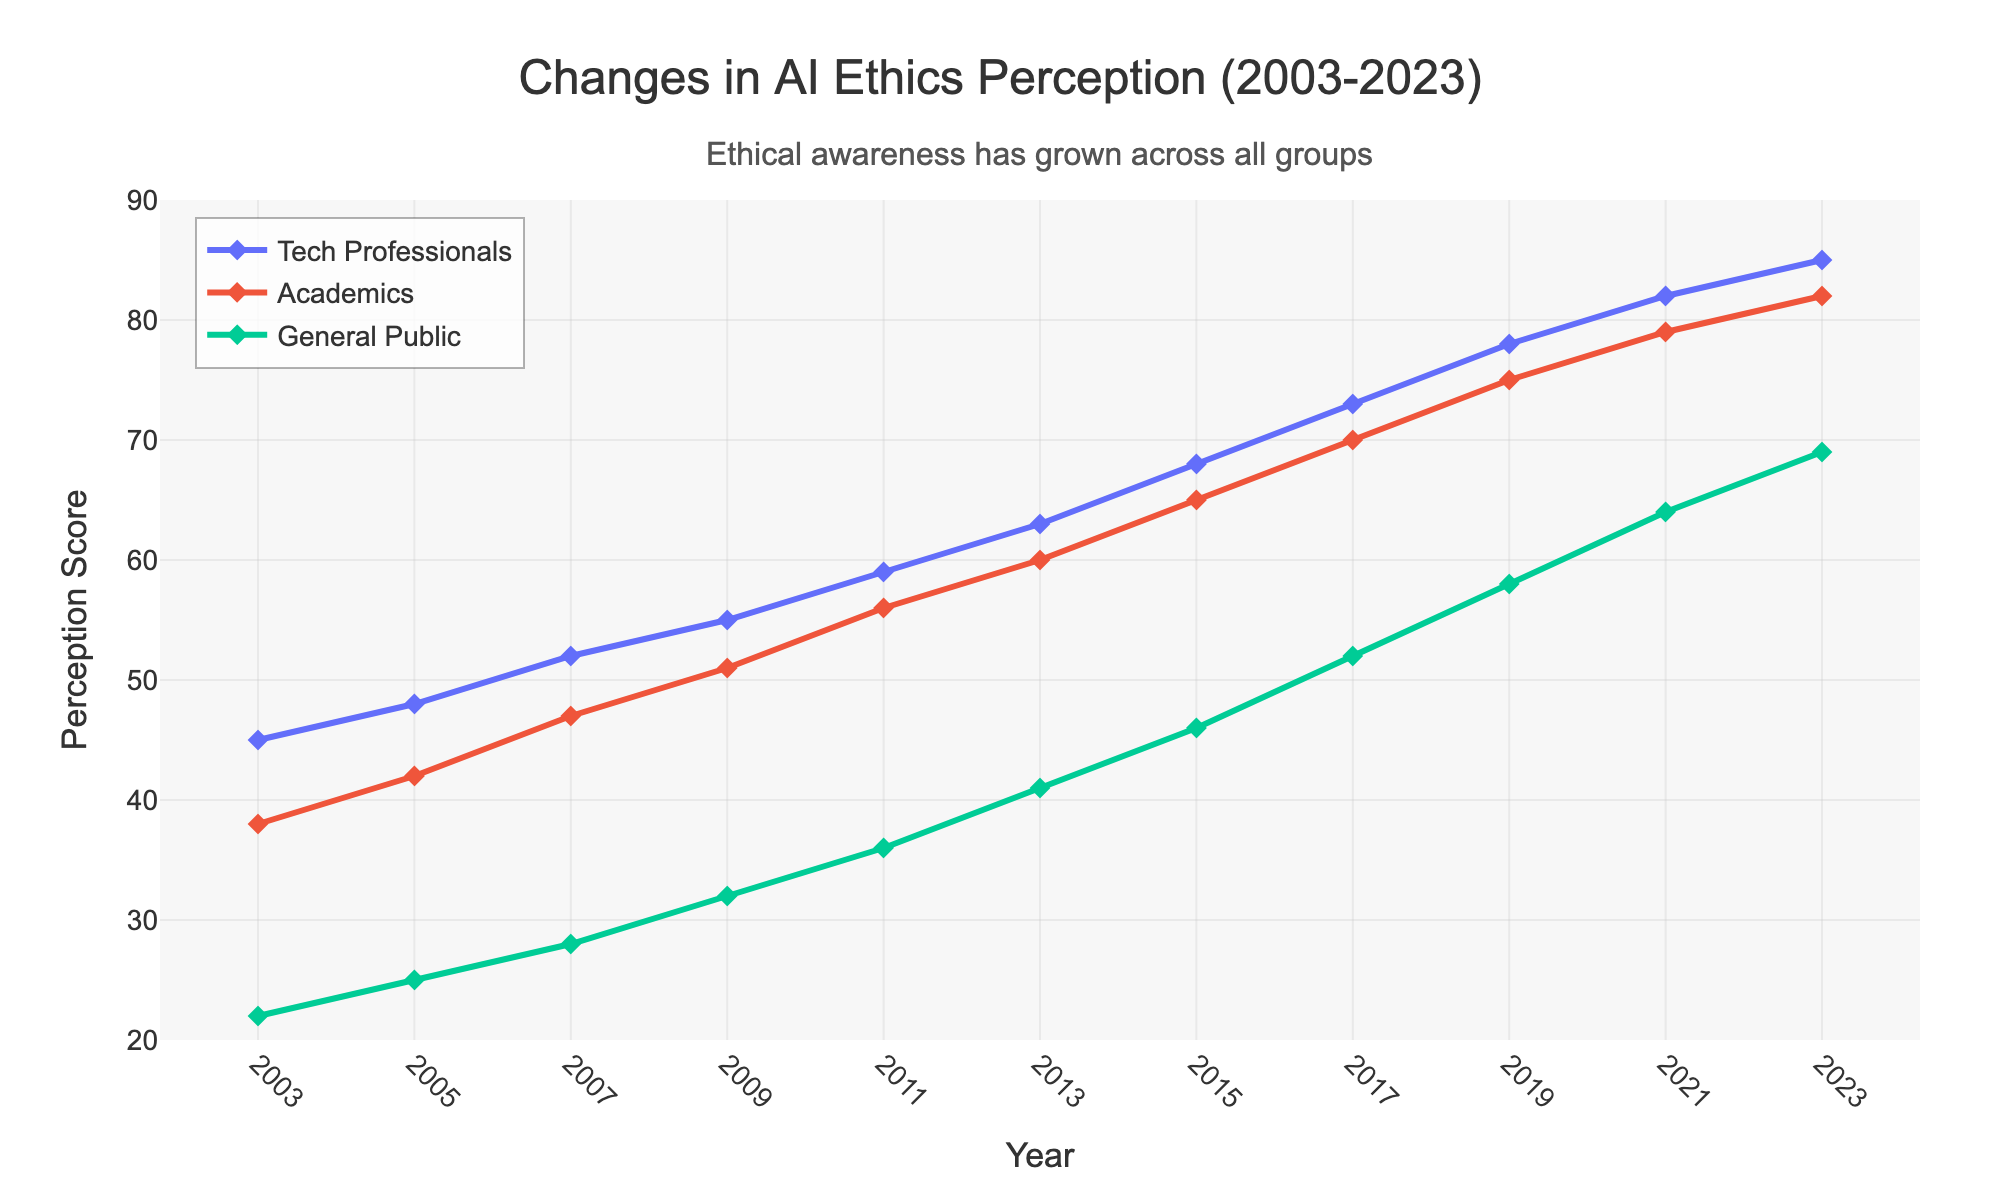Which group has the highest perception score in 2023? By observing the lines on the chart at the year 2023, we see the positions of the markers. The highest marker corresponds to "Tech Professionals".
Answer: Tech Professionals What was the trend in perception score for the General Public from 2003 to 2023? By looking at the line for the General Public from 2003 to 2023, we can see a consistent upward trend across the years.
Answer: Increasing Which year did Academics surpass the perception score of 60? Trace the line for Academics and find the point where it first exceeds 60. This occurs in the year 2013.
Answer: 2013 How much did the perception score of Tech Professionals increase between 2003 and 2023? Subtract the perception score in 2003 for Tech Professionals (45) from the score in 2023 (85): 85 - 45 = 40.
Answer: 40 Compare the perception score of Tech Professionals and General Public in 2011. Which is higher and by how much? In 2011, Tech Professionals had a score of 59 and the General Public had 36. The difference is 59 - 36 = 23, with Tech Professionals being higher.
Answer: Tech Professionals by 23 What is the average perception score of Academics over the two decades? Sum the perception scores of Academics from 2003 to 2023 and divide by the number of years (11): (38+42+47+51+56+60+65+70+75+79+82)/11 = 665/11 = 60.45.
Answer: 60.45 Identify the year when the perception score for the General Public reached 50% of the perception score of Tech Professionals. Find the year where the General Public's score is approximately half of Tech Professionals’. In 2017, Tech Professionals had 73 and the General Public had 52, which is roughly 50% (36.5).
Answer: 2017 How does the visual attribute of the marker style help differentiate between the perception scores of different groups? Each line has its markers styled with unique symbols, such as diamonds, to distinguish between Tech Professionals, Academics, and the General Public.
Answer: Different marker symbols Which group had the least consistent increase in perception score over the years? Examine the lines for variations in their slopes. The line for the General Public has more gradual increments compared to the steeper and more consistent increases of Tech Professionals and Academics.
Answer: General Public 